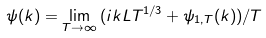<formula> <loc_0><loc_0><loc_500><loc_500>\psi ( k ) = \lim _ { T \to \infty } { ( i k L T ^ { 1 / 3 } + \psi _ { 1 , T } ( k ) ) / T }</formula> 